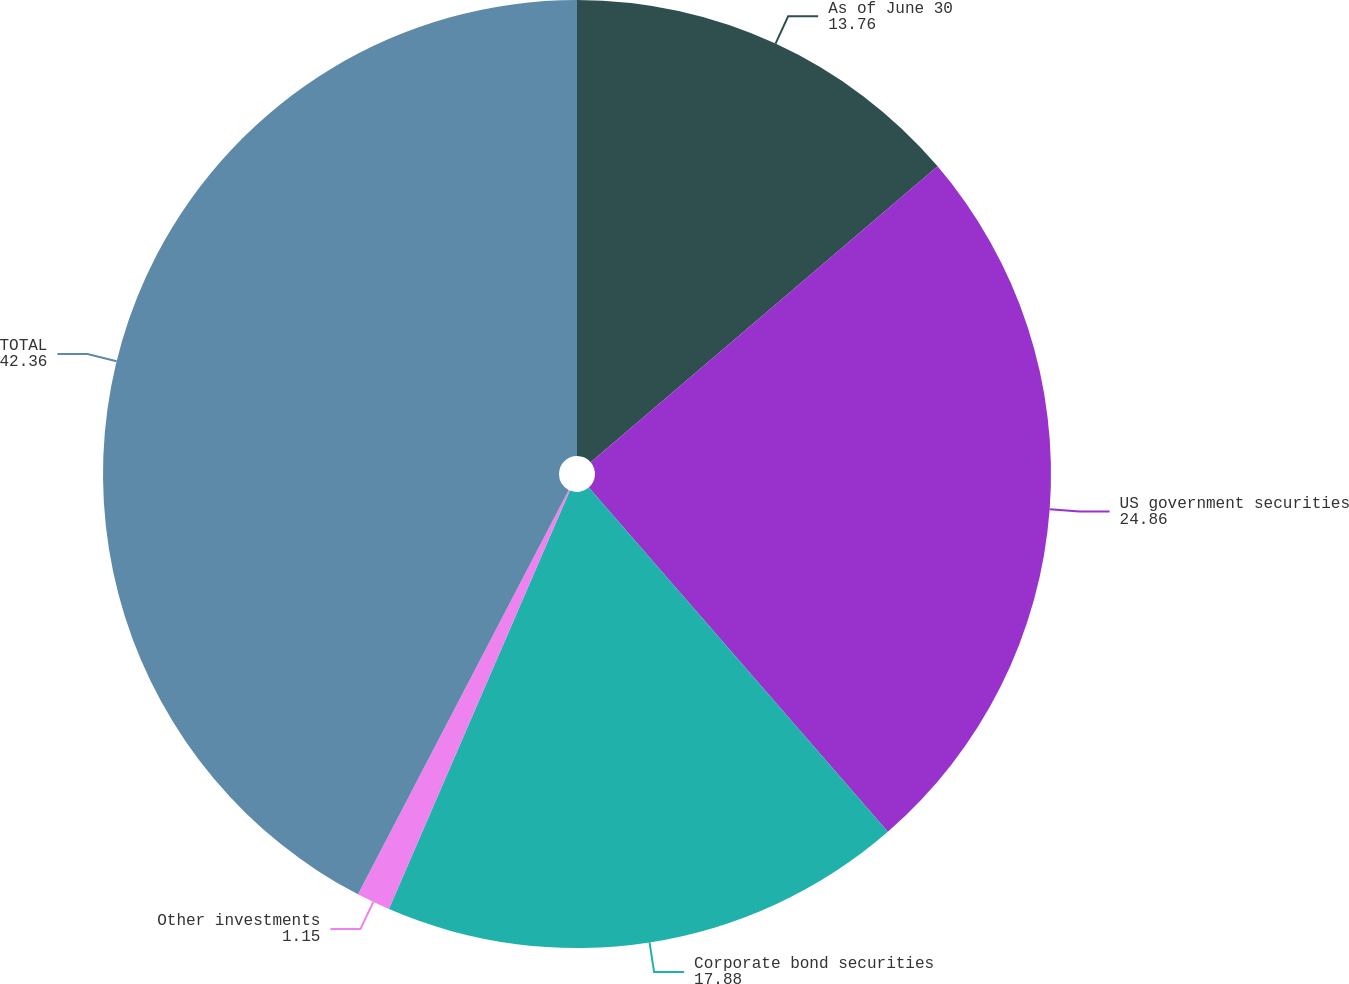Convert chart to OTSL. <chart><loc_0><loc_0><loc_500><loc_500><pie_chart><fcel>As of June 30<fcel>US government securities<fcel>Corporate bond securities<fcel>Other investments<fcel>TOTAL<nl><fcel>13.76%<fcel>24.86%<fcel>17.88%<fcel>1.15%<fcel>42.36%<nl></chart> 